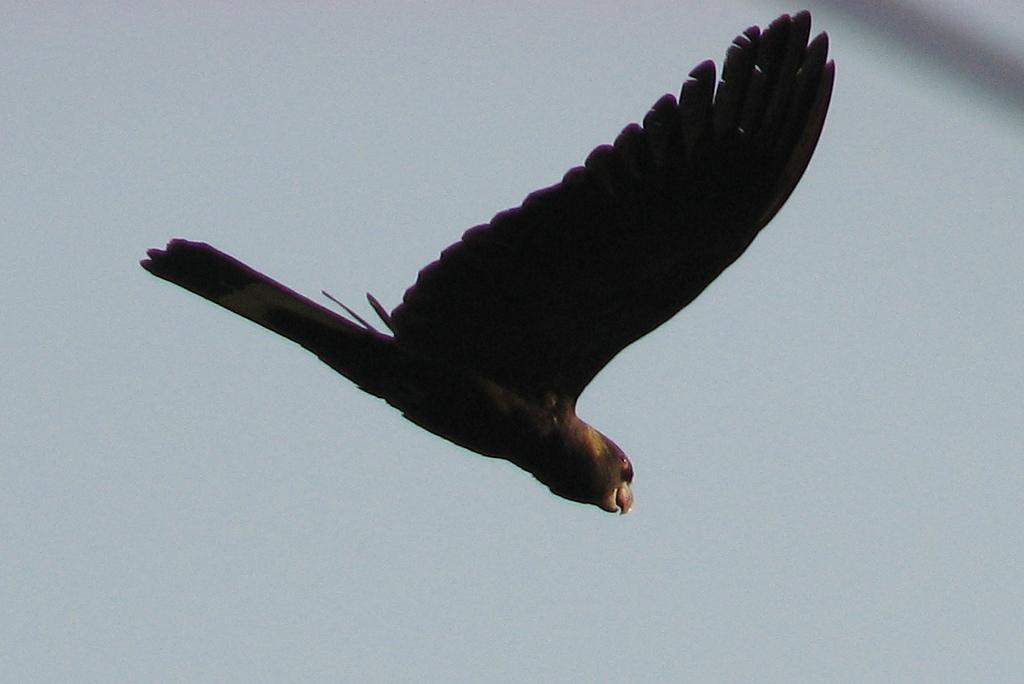Please provide a concise description of this image. In this image I can see there is a bird flying in the sky, it has black wings and black feathers. The sky is clear. 